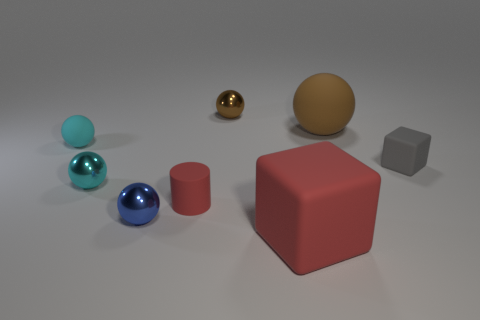Are there any other things that have the same shape as the small red thing?
Make the answer very short. No. Are any small red metal balls visible?
Provide a succinct answer. No. What number of large things are green rubber objects or brown matte objects?
Make the answer very short. 1. Are there more brown rubber objects in front of the matte cylinder than tiny spheres that are behind the tiny cube?
Offer a very short reply. No. Is the red block made of the same material as the tiny cyan sphere behind the small cube?
Provide a short and direct response. Yes. What is the color of the tiny cylinder?
Provide a succinct answer. Red. The small rubber thing in front of the tiny gray rubber object has what shape?
Provide a succinct answer. Cylinder. How many cyan things are tiny objects or small matte cylinders?
Offer a very short reply. 2. There is a tiny cube that is made of the same material as the large red object; what is its color?
Your answer should be very brief. Gray. There is a cylinder; is it the same color as the tiny rubber thing that is on the right side of the brown rubber ball?
Offer a very short reply. No. 